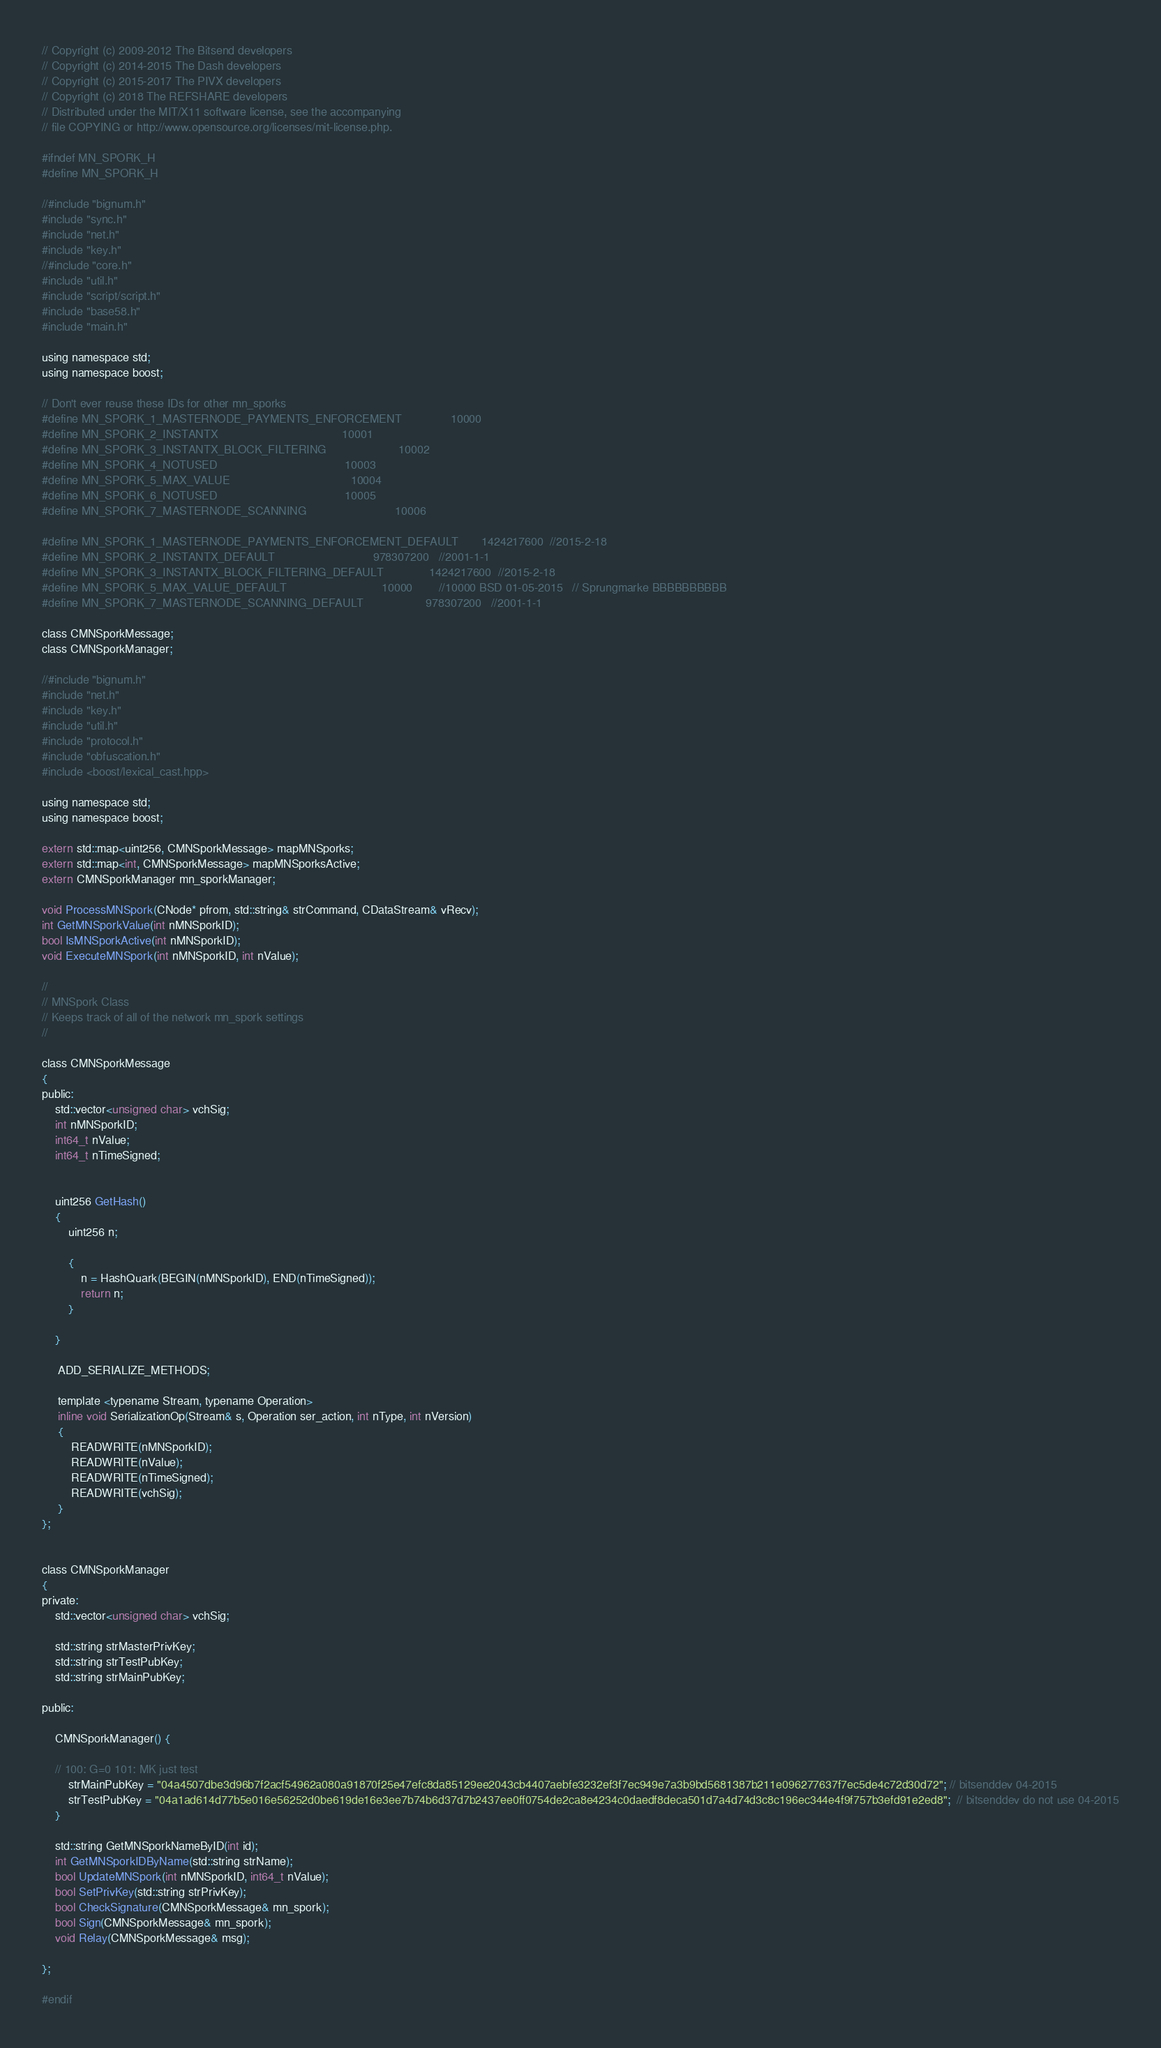<code> <loc_0><loc_0><loc_500><loc_500><_C_>
// Copyright (c) 2009-2012 The Bitsend developers
// Copyright (c) 2014-2015 The Dash developers
// Copyright (c) 2015-2017 The PIVX developers
// Copyright (c) 2018 The REFSHARE developers
// Distributed under the MIT/X11 software license, see the accompanying
// file COPYING or http://www.opensource.org/licenses/mit-license.php.

#ifndef MN_SPORK_H
#define MN_SPORK_H

//#include "bignum.h"
#include "sync.h"
#include "net.h"
#include "key.h"
//#include "core.h"
#include "util.h"
#include "script/script.h"
#include "base58.h"
#include "main.h"

using namespace std;
using namespace boost;

// Don't ever reuse these IDs for other mn_sporks
#define MN_SPORK_1_MASTERNODE_PAYMENTS_ENFORCEMENT               10000
#define MN_SPORK_2_INSTANTX                                      10001
#define MN_SPORK_3_INSTANTX_BLOCK_FILTERING                      10002
#define MN_SPORK_4_NOTUSED                                       10003
#define MN_SPORK_5_MAX_VALUE                                     10004
#define MN_SPORK_6_NOTUSED                                       10005
#define MN_SPORK_7_MASTERNODE_SCANNING                           10006

#define MN_SPORK_1_MASTERNODE_PAYMENTS_ENFORCEMENT_DEFAULT       1424217600  //2015-2-18
#define MN_SPORK_2_INSTANTX_DEFAULT                              978307200   //2001-1-1
#define MN_SPORK_3_INSTANTX_BLOCK_FILTERING_DEFAULT              1424217600  //2015-2-18
#define MN_SPORK_5_MAX_VALUE_DEFAULT                             10000        //10000 BSD 01-05-2015   // Sprungmarke BBBBBBBBBB
#define MN_SPORK_7_MASTERNODE_SCANNING_DEFAULT                   978307200   //2001-1-1

class CMNSporkMessage;
class CMNSporkManager;

//#include "bignum.h"
#include "net.h"
#include "key.h"
#include "util.h"
#include "protocol.h"
#include "obfuscation.h"
#include <boost/lexical_cast.hpp>

using namespace std;
using namespace boost;

extern std::map<uint256, CMNSporkMessage> mapMNSporks;
extern std::map<int, CMNSporkMessage> mapMNSporksActive;
extern CMNSporkManager mn_sporkManager;

void ProcessMNSpork(CNode* pfrom, std::string& strCommand, CDataStream& vRecv);
int GetMNSporkValue(int nMNSporkID);
bool IsMNSporkActive(int nMNSporkID);
void ExecuteMNSpork(int nMNSporkID, int nValue);

//
// MNSpork Class
// Keeps track of all of the network mn_spork settings
//

class CMNSporkMessage
{
public:
    std::vector<unsigned char> vchSig;
    int nMNSporkID;
    int64_t nValue;
    int64_t nTimeSigned;


    uint256 GetHash()
    {
        uint256 n;

        {
            n = HashQuark(BEGIN(nMNSporkID), END(nTimeSigned));
            return n;
        }

    }

     ADD_SERIALIZE_METHODS;

     template <typename Stream, typename Operation>
     inline void SerializationOp(Stream& s, Operation ser_action, int nType, int nVersion)
     {
         READWRITE(nMNSporkID);
         READWRITE(nValue);
         READWRITE(nTimeSigned);
         READWRITE(vchSig);
     }
};


class CMNSporkManager
{
private:
    std::vector<unsigned char> vchSig;

    std::string strMasterPrivKey;
    std::string strTestPubKey;
    std::string strMainPubKey;

public:

    CMNSporkManager() {

    // 100: G=0 101: MK just test
        strMainPubKey = "04a4507dbe3d96b7f2acf54962a080a91870f25e47efc8da85129ee2043cb4407aebfe3232ef3f7ec949e7a3b9bd5681387b211e096277637f7ec5de4c72d30d72"; // bitsenddev 04-2015
        strTestPubKey = "04a1ad614d77b5e016e56252d0be619de16e3ee7b74b6d37d7b2437ee0ff0754de2ca8e4234c0daedf8deca501d7a4d74d3c8c196ec344e4f9f757b3efd91e2ed8";  // bitsenddev do not use 04-2015
    }

    std::string GetMNSporkNameByID(int id);
    int GetMNSporkIDByName(std::string strName);
    bool UpdateMNSpork(int nMNSporkID, int64_t nValue);
    bool SetPrivKey(std::string strPrivKey);
    bool CheckSignature(CMNSporkMessage& mn_spork);
    bool Sign(CMNSporkMessage& mn_spork);
    void Relay(CMNSporkMessage& msg);

};

#endif
</code> 